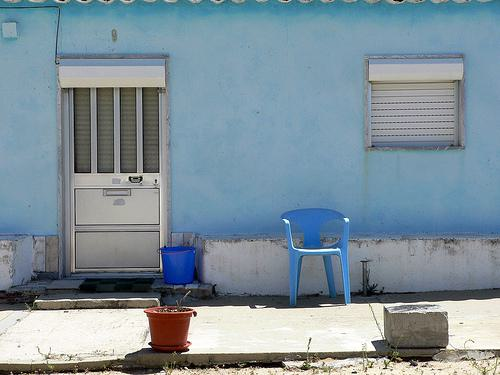What can be inferred about the weather based on the appearance of the sky and surroundings in the image? The sky appears clear and bright, suggesting a sunny day with minimal cloud coverage, which indicates pleasant weather conditions likely favorable for outdoor activities. 